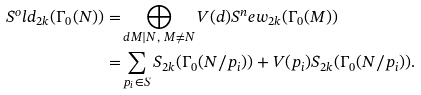<formula> <loc_0><loc_0><loc_500><loc_500>S ^ { o } l d _ { 2 k } ( \Gamma _ { 0 } ( N ) ) = & \bigoplus _ { d M | N , \ M \ne N } V ( d ) S ^ { n } e w _ { 2 k } ( \Gamma _ { 0 } ( M ) ) \\ = & \sum _ { p _ { i } \in S } S _ { 2 k } ( \Gamma _ { 0 } ( N / p _ { i } ) ) + V ( p _ { i } ) S _ { 2 k } ( \Gamma _ { 0 } ( N / p _ { i } ) ) .</formula> 